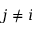<formula> <loc_0><loc_0><loc_500><loc_500>j \neq i</formula> 